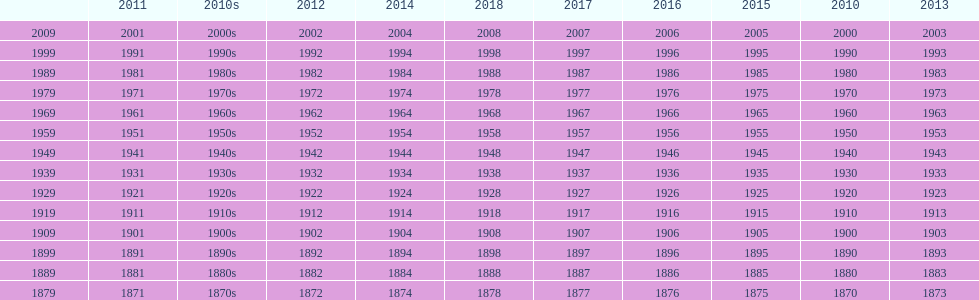What is the earliest year that a film was released? 1870. 